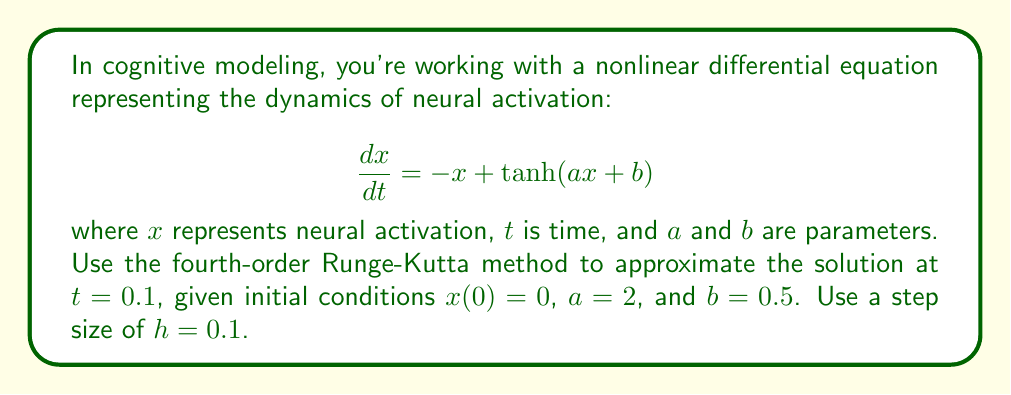Solve this math problem. To solve this problem using the fourth-order Runge-Kutta method, we follow these steps:

1) The general form of the fourth-order Runge-Kutta method is:

   $$x_{n+1} = x_n + \frac{1}{6}(k_1 + 2k_2 + 2k_3 + k_4)$$

   where:
   $$k_1 = hf(t_n, x_n)$$
   $$k_2 = hf(t_n + \frac{h}{2}, x_n + \frac{k_1}{2})$$
   $$k_3 = hf(t_n + \frac{h}{2}, x_n + \frac{k_2}{2})$$
   $$k_4 = hf(t_n + h, x_n + k_3)$$

2) In our case, $f(t, x) = -x + \tanh(ax + b)$, with $a = 2$ and $b = 0.5$.

3) We start with $x_0 = 0$, $t_0 = 0$, and $h = 0.1$.

4) Let's calculate $k_1$:
   $$k_1 = h(-x_0 + \tanh(ax_0 + b)) = 0.1(-0 + \tanh(2 \cdot 0 + 0.5)) = 0.1 \cdot 0.46211716 = 0.046211716$$

5) Now $k_2$:
   $$k_2 = h(-(\frac{k_1}{2}) + \tanh(a(x_0 + \frac{k_1}{2}) + b))$$
   $$= 0.1(-0.023105858 + \tanh(2 \cdot 0.023105858 + 0.5)) = 0.046194678$$

6) For $k_3$:
   $$k_3 = h(-(\frac{k_2}{2}) + \tanh(a(x_0 + \frac{k_2}{2}) + b))$$
   $$= 0.1(-0.023097339 + \tanh(2 \cdot 0.023097339 + 0.5)) = 0.046194691$$

7) Finally, $k_4$:
   $$k_4 = h(-(x_0 + k_3) + \tanh(a(x_0 + k_3) + b))$$
   $$= 0.1(-0.046194691 + \tanh(2 \cdot 0.046194691 + 0.5)) = 0.046177648$$

8) Now we can calculate $x_1$:
   $$x_1 = x_0 + \frac{1}{6}(k_1 + 2k_2 + 2k_3 + k_4)$$
   $$= 0 + \frac{1}{6}(0.046211716 + 2 \cdot 0.046194678 + 2 \cdot 0.046194691 + 0.046177648)$$
   $$= 0.046194684$$

Therefore, the approximate solution at $t = 0.1$ is $x(0.1) \approx 0.046194684$.
Answer: 0.046194684 